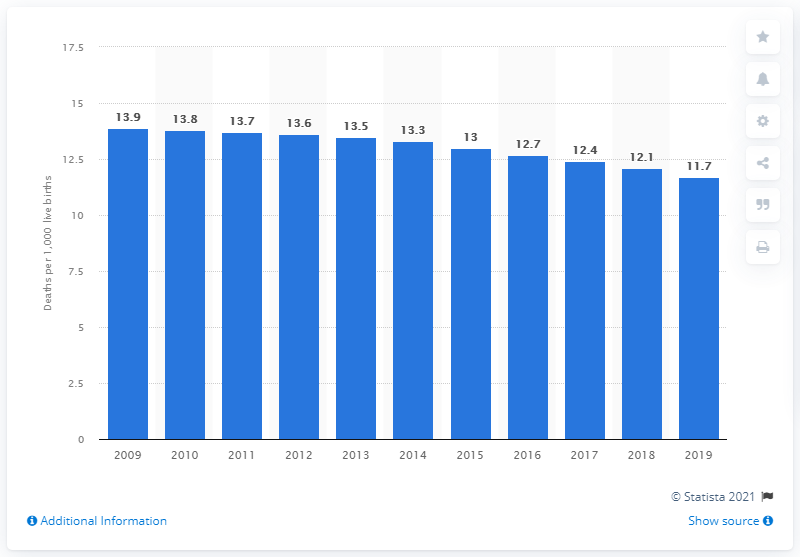Give some essential details in this illustration. In 2019, the infant mortality rate in Barbados was 11.7 deaths per 1,000 live births. 